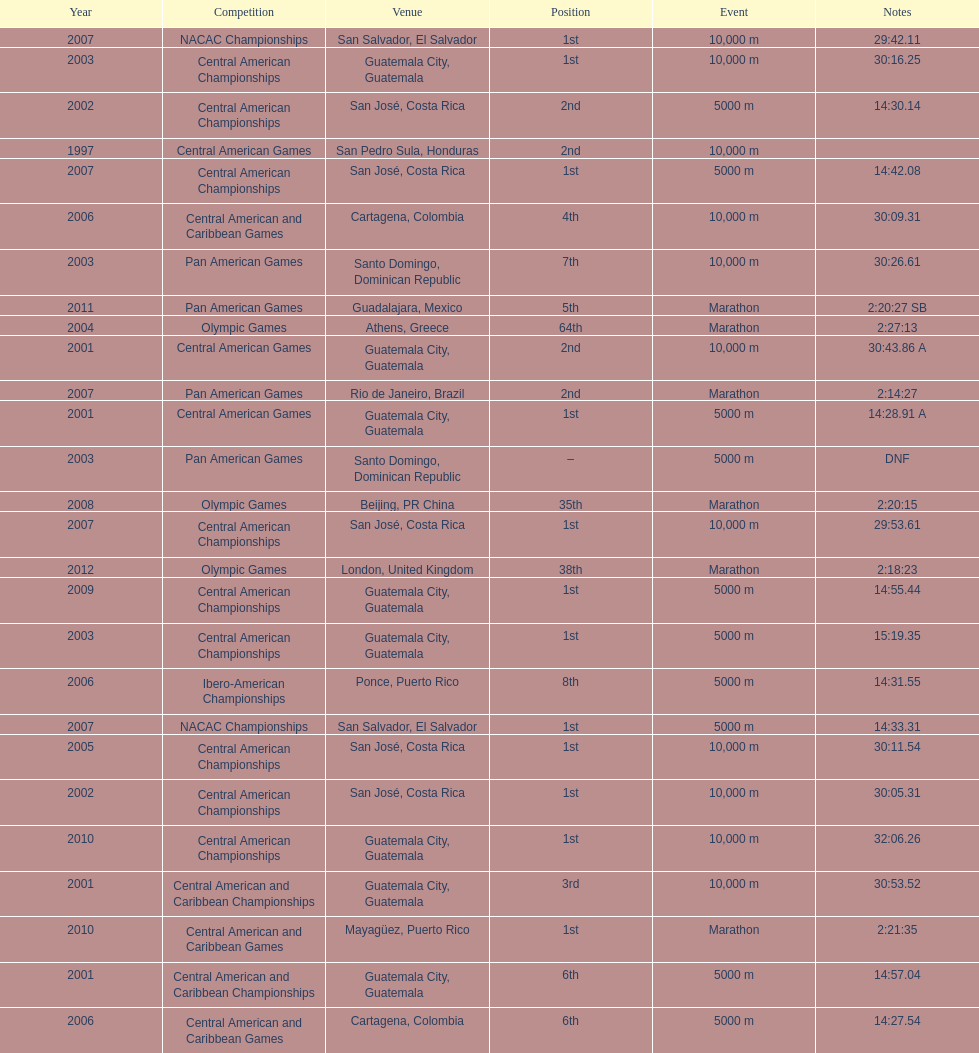Tell me the number of times they competed in guatamala. 5. Parse the table in full. {'header': ['Year', 'Competition', 'Venue', 'Position', 'Event', 'Notes'], 'rows': [['2007', 'NACAC Championships', 'San Salvador, El Salvador', '1st', '10,000 m', '29:42.11'], ['2003', 'Central American Championships', 'Guatemala City, Guatemala', '1st', '10,000 m', '30:16.25'], ['2002', 'Central American Championships', 'San José, Costa Rica', '2nd', '5000 m', '14:30.14'], ['1997', 'Central American Games', 'San Pedro Sula, Honduras', '2nd', '10,000 m', ''], ['2007', 'Central American Championships', 'San José, Costa Rica', '1st', '5000 m', '14:42.08'], ['2006', 'Central American and Caribbean Games', 'Cartagena, Colombia', '4th', '10,000 m', '30:09.31'], ['2003', 'Pan American Games', 'Santo Domingo, Dominican Republic', '7th', '10,000 m', '30:26.61'], ['2011', 'Pan American Games', 'Guadalajara, Mexico', '5th', 'Marathon', '2:20:27 SB'], ['2004', 'Olympic Games', 'Athens, Greece', '64th', 'Marathon', '2:27:13'], ['2001', 'Central American Games', 'Guatemala City, Guatemala', '2nd', '10,000 m', '30:43.86 A'], ['2007', 'Pan American Games', 'Rio de Janeiro, Brazil', '2nd', 'Marathon', '2:14:27'], ['2001', 'Central American Games', 'Guatemala City, Guatemala', '1st', '5000 m', '14:28.91 A'], ['2003', 'Pan American Games', 'Santo Domingo, Dominican Republic', '–', '5000 m', 'DNF'], ['2008', 'Olympic Games', 'Beijing, PR China', '35th', 'Marathon', '2:20:15'], ['2007', 'Central American Championships', 'San José, Costa Rica', '1st', '10,000 m', '29:53.61'], ['2012', 'Olympic Games', 'London, United Kingdom', '38th', 'Marathon', '2:18:23'], ['2009', 'Central American Championships', 'Guatemala City, Guatemala', '1st', '5000 m', '14:55.44'], ['2003', 'Central American Championships', 'Guatemala City, Guatemala', '1st', '5000 m', '15:19.35'], ['2006', 'Ibero-American Championships', 'Ponce, Puerto Rico', '8th', '5000 m', '14:31.55'], ['2007', 'NACAC Championships', 'San Salvador, El Salvador', '1st', '5000 m', '14:33.31'], ['2005', 'Central American Championships', 'San José, Costa Rica', '1st', '10,000 m', '30:11.54'], ['2002', 'Central American Championships', 'San José, Costa Rica', '1st', '10,000 m', '30:05.31'], ['2010', 'Central American Championships', 'Guatemala City, Guatemala', '1st', '10,000 m', '32:06.26'], ['2001', 'Central American and Caribbean Championships', 'Guatemala City, Guatemala', '3rd', '10,000 m', '30:53.52'], ['2010', 'Central American and Caribbean Games', 'Mayagüez, Puerto Rico', '1st', 'Marathon', '2:21:35'], ['2001', 'Central American and Caribbean Championships', 'Guatemala City, Guatemala', '6th', '5000 m', '14:57.04'], ['2006', 'Central American and Caribbean Games', 'Cartagena, Colombia', '6th', '5000 m', '14:27.54']]} 